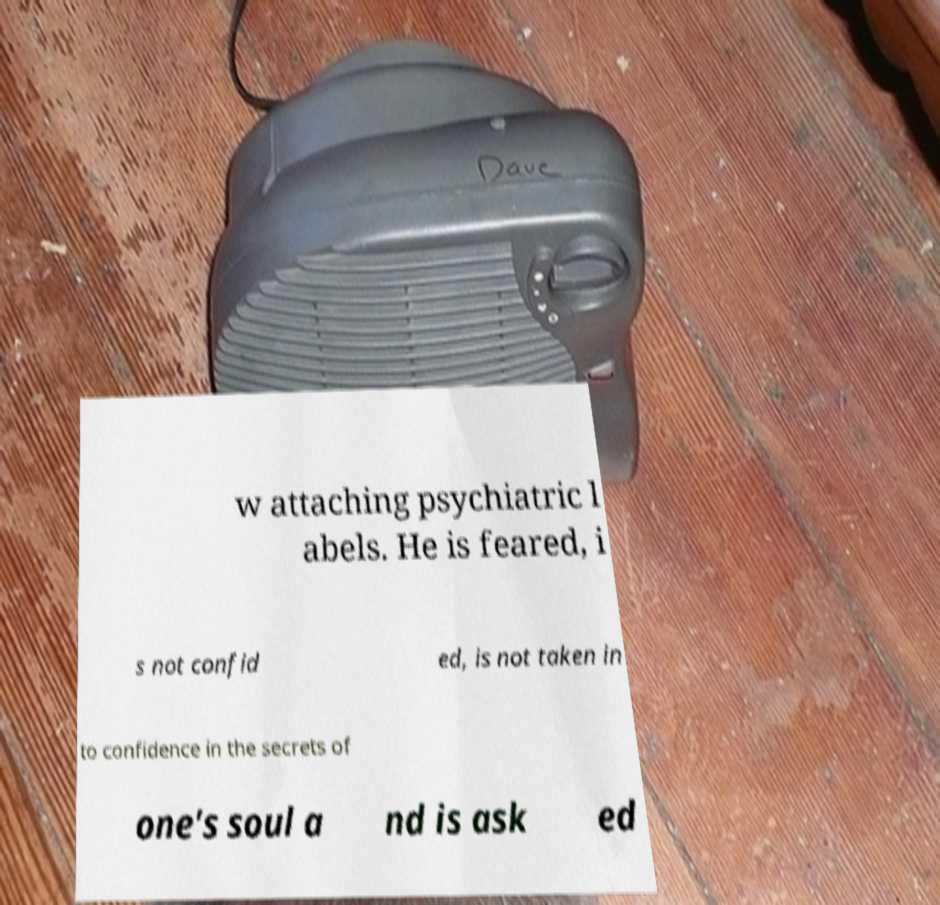For documentation purposes, I need the text within this image transcribed. Could you provide that? w attaching psychiatric l abels. He is feared, i s not confid ed, is not taken in to confidence in the secrets of one's soul a nd is ask ed 